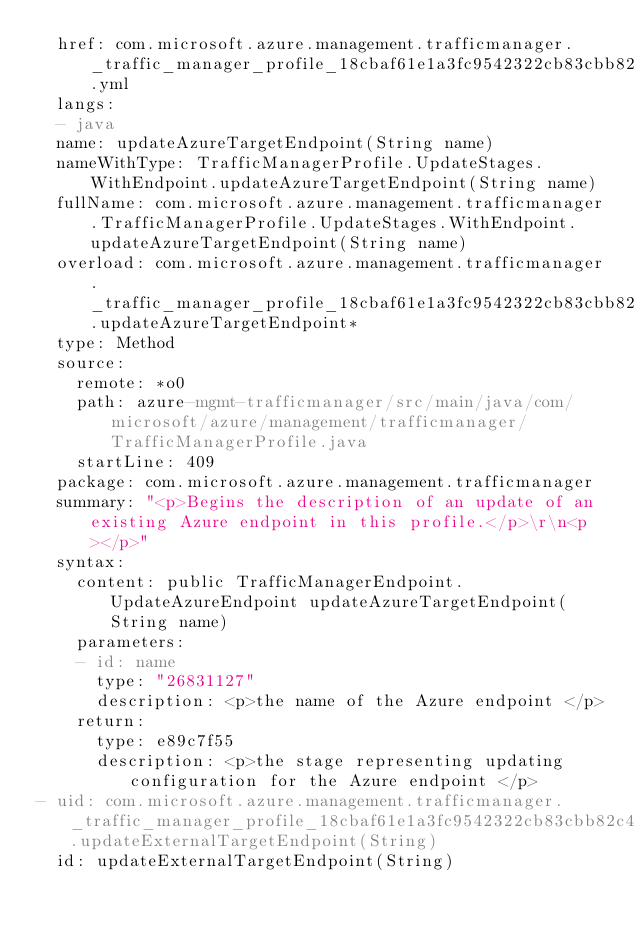<code> <loc_0><loc_0><loc_500><loc_500><_YAML_>  href: com.microsoft.azure.management.trafficmanager._traffic_manager_profile_18cbaf61e1a3fc9542322cb83cbb82c4d.yml
  langs:
  - java
  name: updateAzureTargetEndpoint(String name)
  nameWithType: TrafficManagerProfile.UpdateStages.WithEndpoint.updateAzureTargetEndpoint(String name)
  fullName: com.microsoft.azure.management.trafficmanager.TrafficManagerProfile.UpdateStages.WithEndpoint.updateAzureTargetEndpoint(String name)
  overload: com.microsoft.azure.management.trafficmanager._traffic_manager_profile_18cbaf61e1a3fc9542322cb83cbb82c4d.updateAzureTargetEndpoint*
  type: Method
  source:
    remote: *o0
    path: azure-mgmt-trafficmanager/src/main/java/com/microsoft/azure/management/trafficmanager/TrafficManagerProfile.java
    startLine: 409
  package: com.microsoft.azure.management.trafficmanager
  summary: "<p>Begins the description of an update of an existing Azure endpoint in this profile.</p>\r\n<p></p>"
  syntax:
    content: public TrafficManagerEndpoint.UpdateAzureEndpoint updateAzureTargetEndpoint(String name)
    parameters:
    - id: name
      type: "26831127"
      description: <p>the name of the Azure endpoint </p>
    return:
      type: e89c7f55
      description: <p>the stage representing updating configuration for the Azure endpoint </p>
- uid: com.microsoft.azure.management.trafficmanager._traffic_manager_profile_18cbaf61e1a3fc9542322cb83cbb82c4d.updateExternalTargetEndpoint(String)
  id: updateExternalTargetEndpoint(String)</code> 